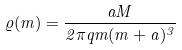<formula> <loc_0><loc_0><loc_500><loc_500>\varrho ( m ) = \frac { a M } { 2 \pi q m ( m + a ) ^ { 3 } }</formula> 